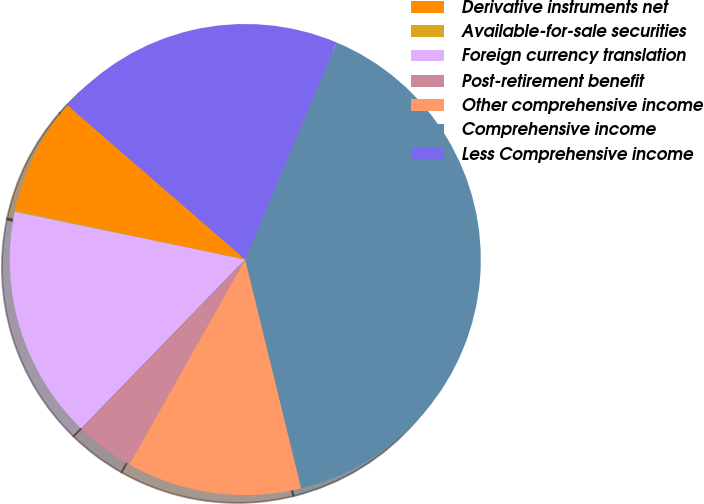Convert chart to OTSL. <chart><loc_0><loc_0><loc_500><loc_500><pie_chart><fcel>Derivative instruments net<fcel>Available-for-sale securities<fcel>Foreign currency translation<fcel>Post-retirement benefit<fcel>Other comprehensive income<fcel>Comprehensive income<fcel>Less Comprehensive income<nl><fcel>8.04%<fcel>0.09%<fcel>15.99%<fcel>4.07%<fcel>12.01%<fcel>39.84%<fcel>19.96%<nl></chart> 